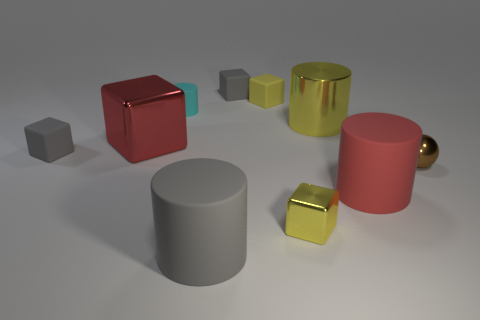Subtract all yellow metallic blocks. How many blocks are left? 4 Subtract 1 cylinders. How many cylinders are left? 3 Subtract all blue cubes. How many green cylinders are left? 0 Subtract all small cyan shiny blocks. Subtract all large yellow things. How many objects are left? 9 Add 5 brown metal things. How many brown metal things are left? 6 Add 2 red metal cylinders. How many red metal cylinders exist? 2 Subtract all gray cubes. How many cubes are left? 3 Subtract 1 red cubes. How many objects are left? 9 Subtract all balls. How many objects are left? 9 Subtract all brown cylinders. Subtract all red balls. How many cylinders are left? 4 